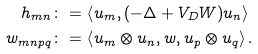<formula> <loc_0><loc_0><loc_500><loc_500>h _ { m n } \colon = \, & \left \langle u _ { m } , ( - \Delta + V _ { D } W ) u _ { n } \right \rangle \\ w _ { m n p q } \colon = \, & \left \langle u _ { m } \otimes u _ { n } , w , u _ { p } \otimes u _ { q } \right \rangle .</formula> 